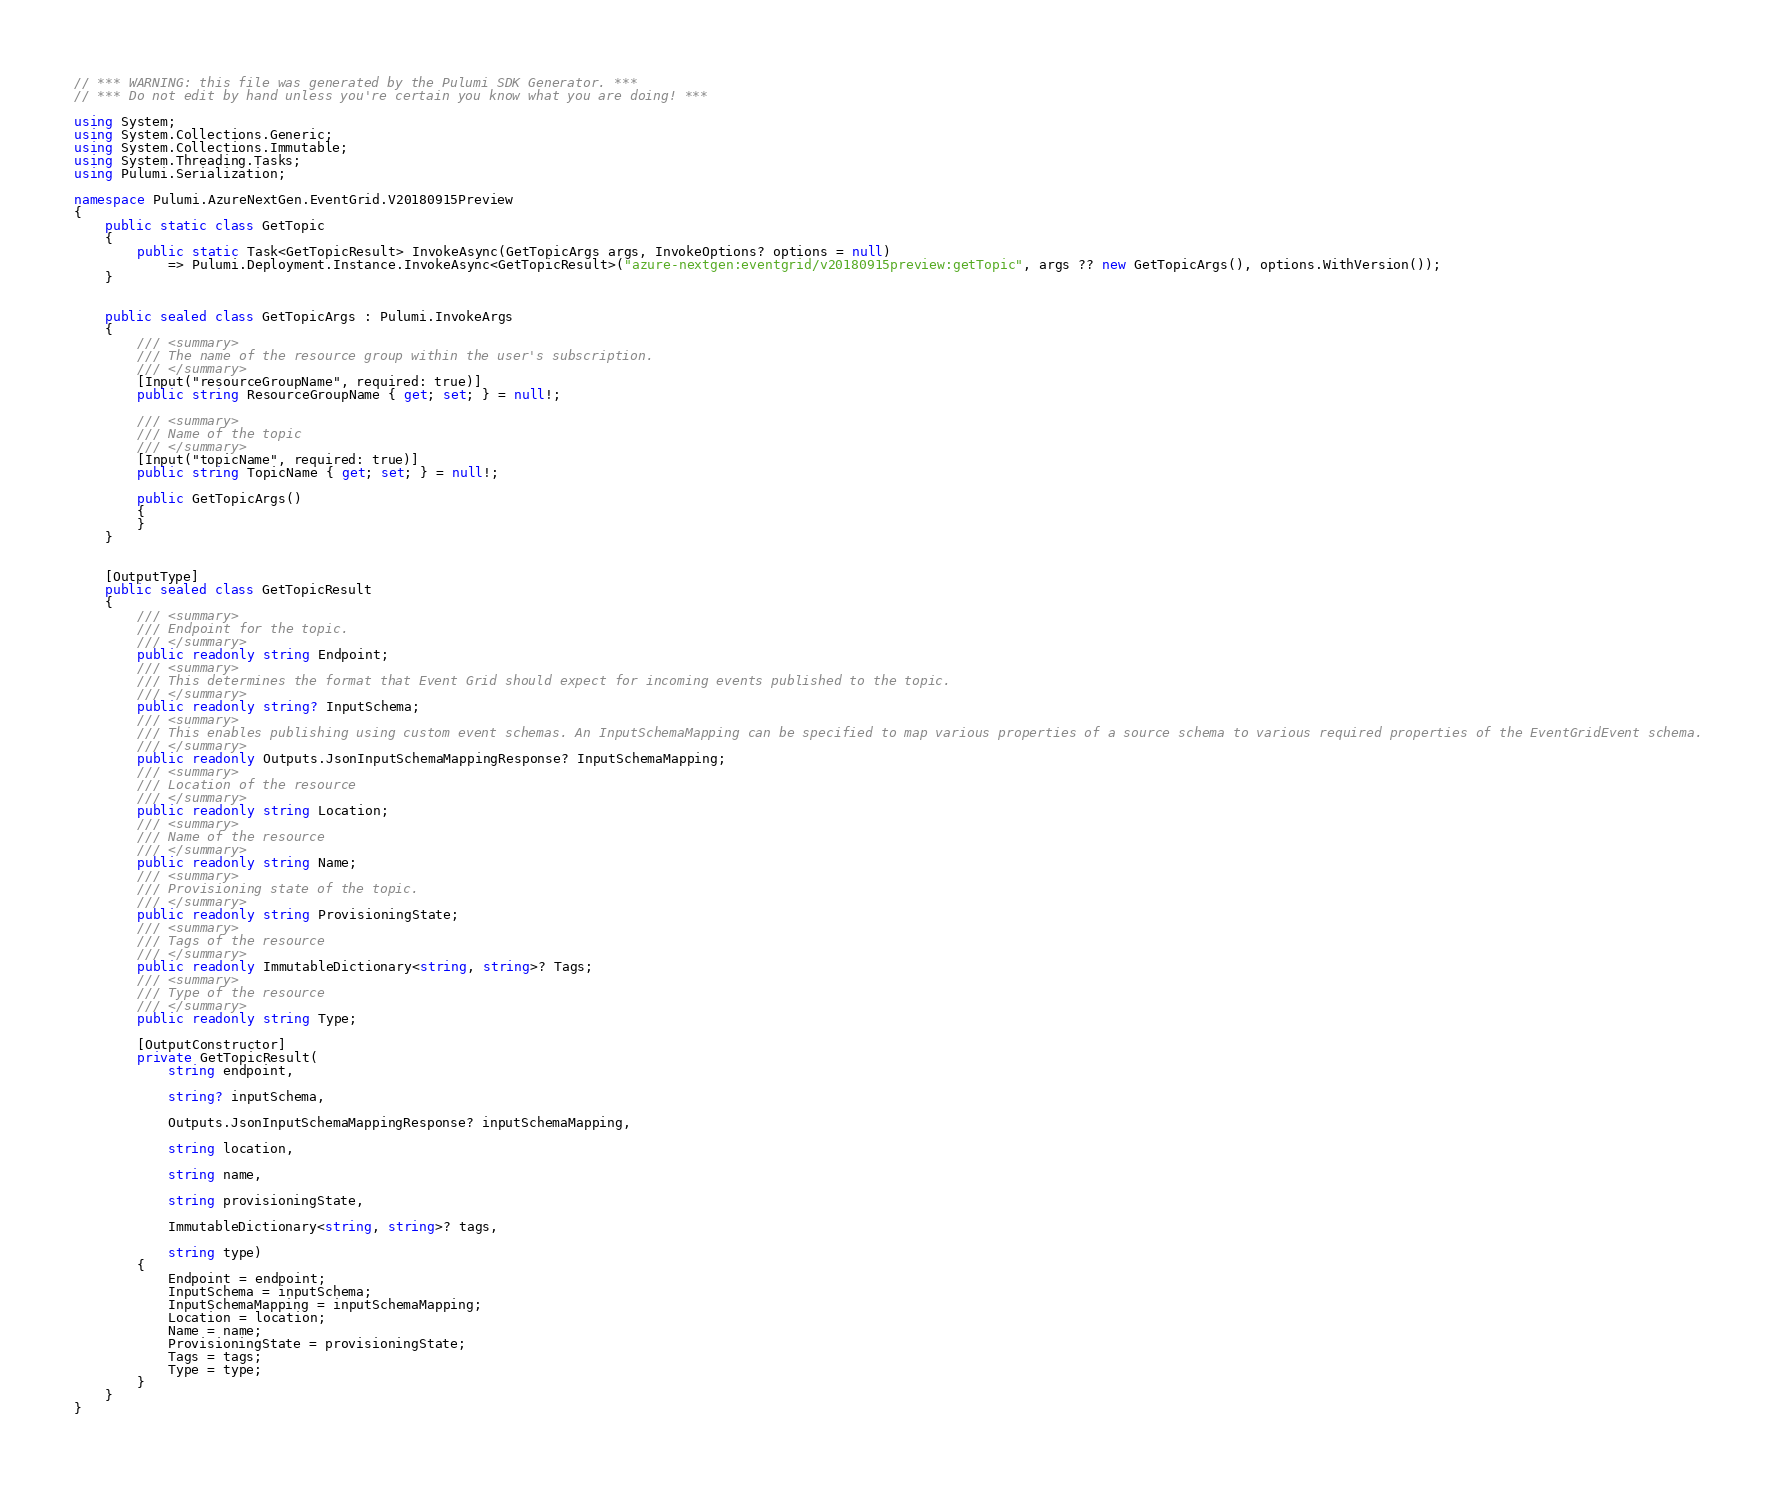Convert code to text. <code><loc_0><loc_0><loc_500><loc_500><_C#_>// *** WARNING: this file was generated by the Pulumi SDK Generator. ***
// *** Do not edit by hand unless you're certain you know what you are doing! ***

using System;
using System.Collections.Generic;
using System.Collections.Immutable;
using System.Threading.Tasks;
using Pulumi.Serialization;

namespace Pulumi.AzureNextGen.EventGrid.V20180915Preview
{
    public static class GetTopic
    {
        public static Task<GetTopicResult> InvokeAsync(GetTopicArgs args, InvokeOptions? options = null)
            => Pulumi.Deployment.Instance.InvokeAsync<GetTopicResult>("azure-nextgen:eventgrid/v20180915preview:getTopic", args ?? new GetTopicArgs(), options.WithVersion());
    }


    public sealed class GetTopicArgs : Pulumi.InvokeArgs
    {
        /// <summary>
        /// The name of the resource group within the user's subscription.
        /// </summary>
        [Input("resourceGroupName", required: true)]
        public string ResourceGroupName { get; set; } = null!;

        /// <summary>
        /// Name of the topic
        /// </summary>
        [Input("topicName", required: true)]
        public string TopicName { get; set; } = null!;

        public GetTopicArgs()
        {
        }
    }


    [OutputType]
    public sealed class GetTopicResult
    {
        /// <summary>
        /// Endpoint for the topic.
        /// </summary>
        public readonly string Endpoint;
        /// <summary>
        /// This determines the format that Event Grid should expect for incoming events published to the topic.
        /// </summary>
        public readonly string? InputSchema;
        /// <summary>
        /// This enables publishing using custom event schemas. An InputSchemaMapping can be specified to map various properties of a source schema to various required properties of the EventGridEvent schema.
        /// </summary>
        public readonly Outputs.JsonInputSchemaMappingResponse? InputSchemaMapping;
        /// <summary>
        /// Location of the resource
        /// </summary>
        public readonly string Location;
        /// <summary>
        /// Name of the resource
        /// </summary>
        public readonly string Name;
        /// <summary>
        /// Provisioning state of the topic.
        /// </summary>
        public readonly string ProvisioningState;
        /// <summary>
        /// Tags of the resource
        /// </summary>
        public readonly ImmutableDictionary<string, string>? Tags;
        /// <summary>
        /// Type of the resource
        /// </summary>
        public readonly string Type;

        [OutputConstructor]
        private GetTopicResult(
            string endpoint,

            string? inputSchema,

            Outputs.JsonInputSchemaMappingResponse? inputSchemaMapping,

            string location,

            string name,

            string provisioningState,

            ImmutableDictionary<string, string>? tags,

            string type)
        {
            Endpoint = endpoint;
            InputSchema = inputSchema;
            InputSchemaMapping = inputSchemaMapping;
            Location = location;
            Name = name;
            ProvisioningState = provisioningState;
            Tags = tags;
            Type = type;
        }
    }
}
</code> 